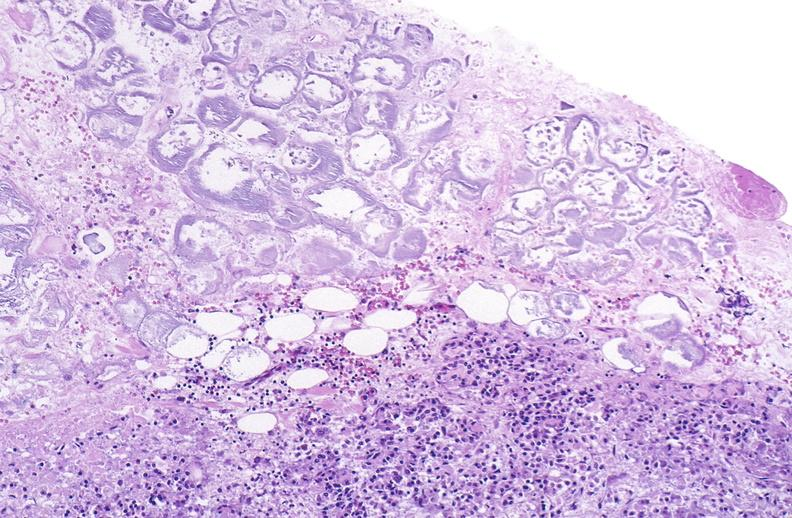does this image show pancreatic fat necrosis?
Answer the question using a single word or phrase. Yes 